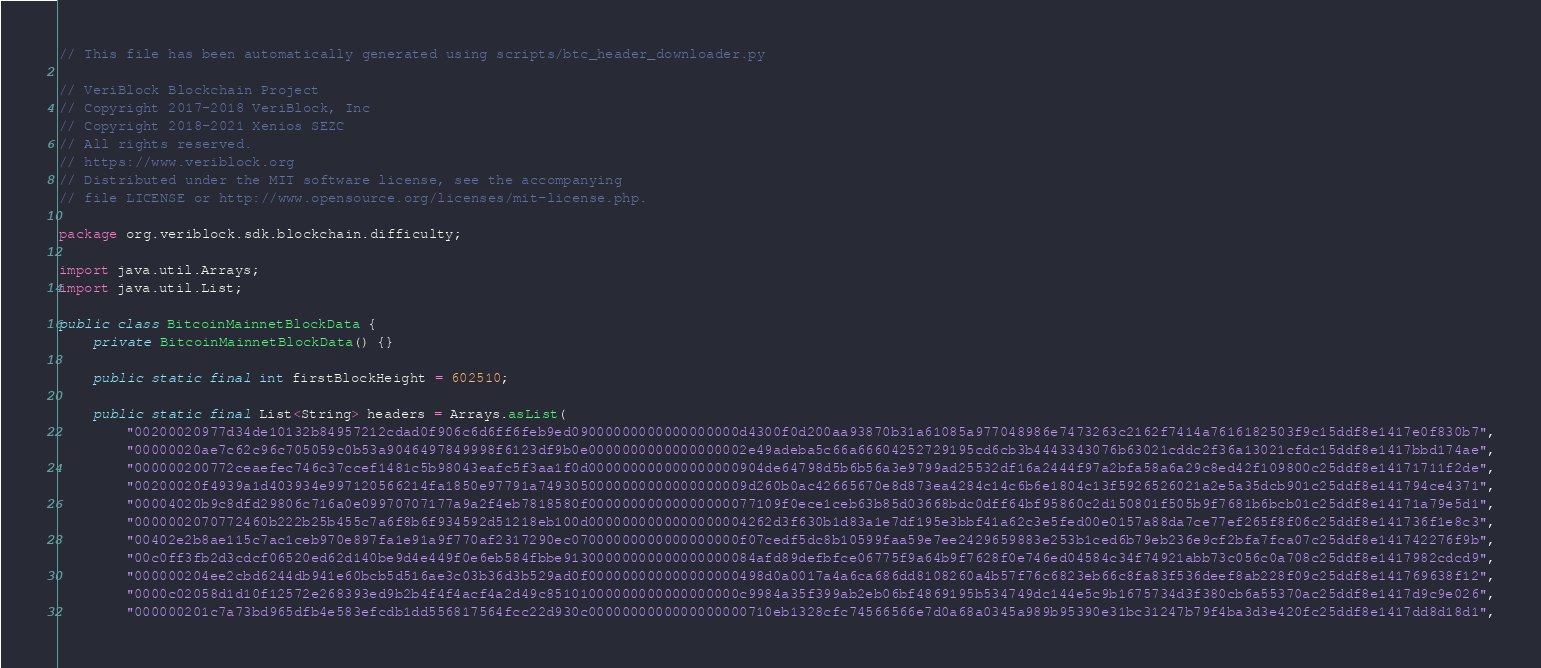<code> <loc_0><loc_0><loc_500><loc_500><_Java_>// This file has been automatically generated using scripts/btc_header_downloader.py

// VeriBlock Blockchain Project
// Copyright 2017-2018 VeriBlock, Inc
// Copyright 2018-2021 Xenios SEZC
// All rights reserved.
// https://www.veriblock.org
// Distributed under the MIT software license, see the accompanying
// file LICENSE or http://www.opensource.org/licenses/mit-license.php.

package org.veriblock.sdk.blockchain.difficulty;

import java.util.Arrays;
import java.util.List;

public class BitcoinMainnetBlockData {
    private BitcoinMainnetBlockData() {}

    public static final int firstBlockHeight = 602510;

    public static final List<String> headers = Arrays.asList(
        "00200020977d34de10132b84957212cdad0f906c6d6ff6feb9ed09000000000000000000d4300f0d200aa93870b31a61085a977048986e7473263c2162f7414a7616182503f9c15ddf8e1417e0f830b7",
        "00000020ae7c62c96c705059c0b53a9046497849998f6123df9b0e0000000000000000002e49adeba5c66a66604252729195cd6cb3b4443343076b63021cddc2f36a13021cfdc15ddf8e1417bbd174ae",
        "000000200772ceaefec746c37ccef1481c5b98043eafc5f3aa1f0d000000000000000000904de64798d5b6b56a3e9799ad25532df16a2444f97a2bfa58a6a29c8ed42f109800c25ddf8e14171711f2de",
        "00200020f4939a1d403934e997120566214fa1850e97791a7493050000000000000000009d260b0ac42665670e8d873ea4284c14c6b6e1804c13f5926526021a2e5a35dcb901c25ddf8e141794ce4371",
        "00004020b9c8dfd29806c716a0e09970707177a9a2f4eb7818580f00000000000000000077109f0ece1ceb63b85d03668bdc0dff64bf95860c2d150801f505b9f7681b6bcb01c25ddf8e14171a79e5d1",
        "0000002070772460b222b25b455c7a6f8b6f934592d51218eb100d0000000000000000004262d3f630b1d83a1e7df195e3bbf41a62c3e5fed00e0157a88da7ce77ef265f8f06c25ddf8e141736f1e8c3",
        "00402e2b8ae115c7ac1ceb970e897fa1e91a9f770af2317290ec07000000000000000000f07cedf5dc8b10599faa59e7ee2429659883e253b1ced6b79eb236e9cf2bfa7fca07c25ddf8e141742276f9b",
        "00c0ff3fb2d3cdcf06520ed62d140be9d4e449f0e6eb584fbbe91300000000000000000084afd89defbfce06775f9a64b9f7628f0e746ed04584c34f74921abb73c056c0a708c25ddf8e1417982cdcd9",
        "000000204ee2cbd6244db941e60bcb5d516ae3c03b36d3b529ad0f000000000000000000498d0a0017a4a6ca686dd8108260a4b57f76c6823eb66c8fa83f536deef8ab228f09c25ddf8e141769638f12",
        "0000c02058d1d10f12572e268393ed9b2b4f4f4acf4a2d49c85101000000000000000000c9984a35f399ab2eb06bf4869195b534749dc144e5c9b1675734d3f380cb6a55370ac25ddf8e1417d9c9e026",
        "000000201c7a73bd965dfb4e583efcdb1dd556817564fcc22d930c0000000000000000000710eb1328cfc74566566e7d0a68a0345a989b95390e31bc31247b79f4ba3d3e420fc25ddf8e1417dd8d18d1",</code> 